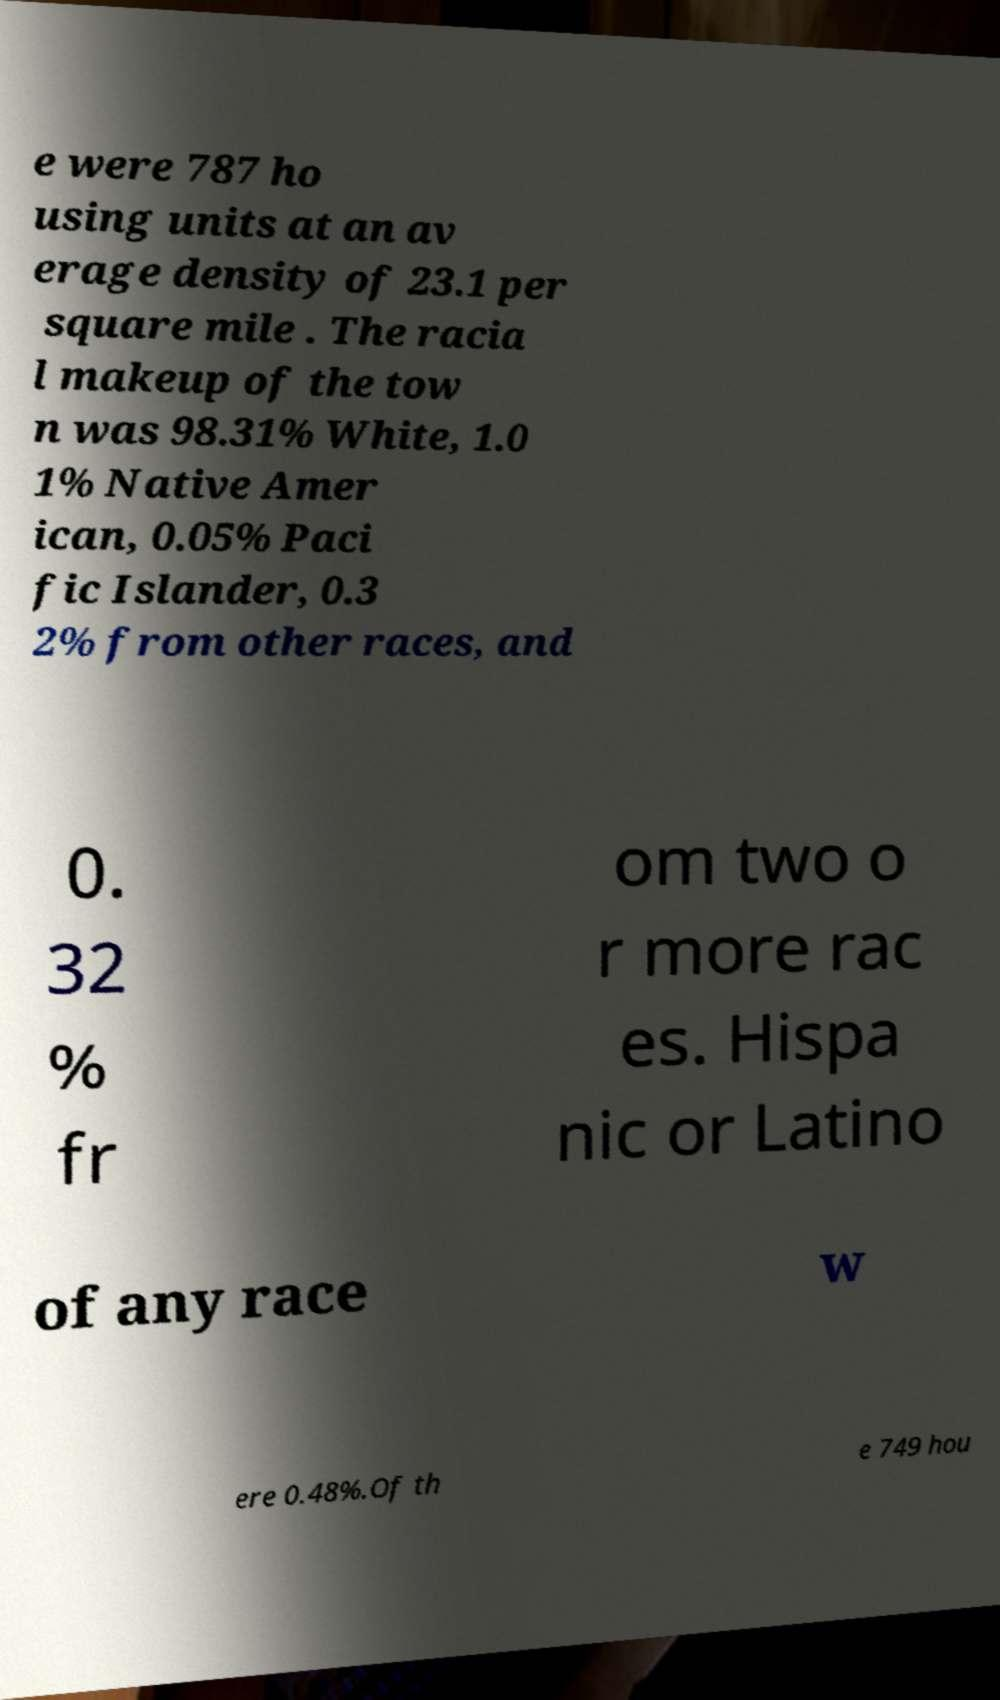I need the written content from this picture converted into text. Can you do that? e were 787 ho using units at an av erage density of 23.1 per square mile . The racia l makeup of the tow n was 98.31% White, 1.0 1% Native Amer ican, 0.05% Paci fic Islander, 0.3 2% from other races, and 0. 32 % fr om two o r more rac es. Hispa nic or Latino of any race w ere 0.48%.Of th e 749 hou 